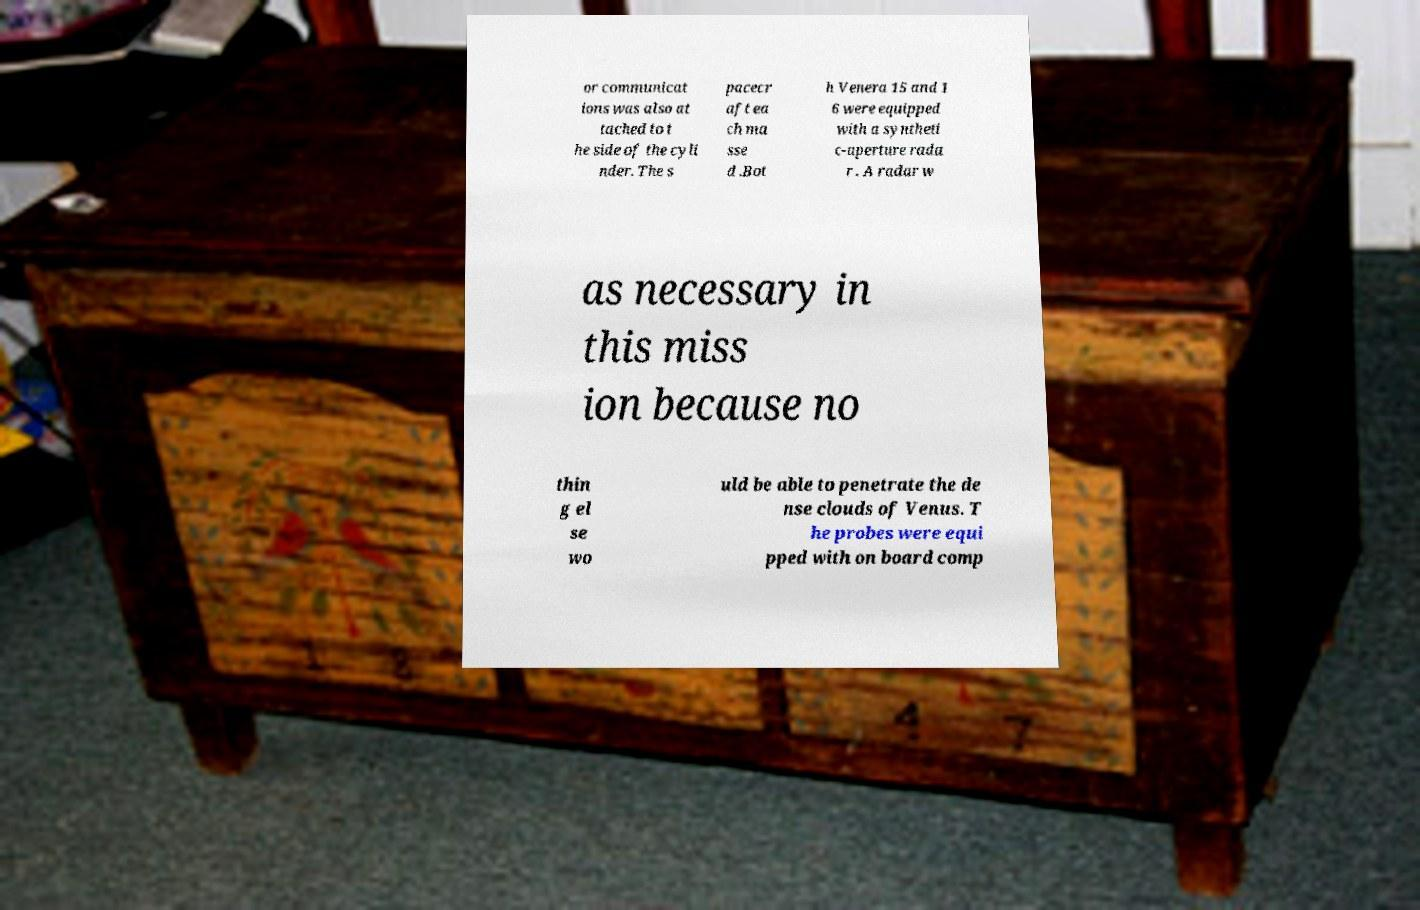Could you assist in decoding the text presented in this image and type it out clearly? or communicat ions was also at tached to t he side of the cyli nder. The s pacecr aft ea ch ma sse d .Bot h Venera 15 and 1 6 were equipped with a syntheti c-aperture rada r . A radar w as necessary in this miss ion because no thin g el se wo uld be able to penetrate the de nse clouds of Venus. T he probes were equi pped with on board comp 